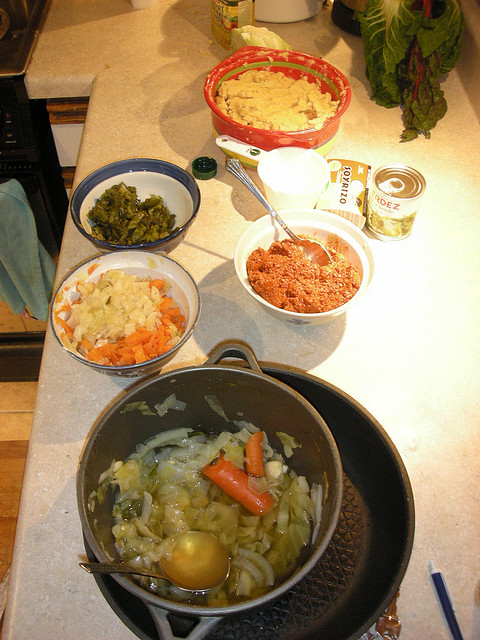Are there any cultural clues visible in the ingredients or cooking utensils? The ingredients appear to be quite general and could be found in various cuisines around the world, so it's difficult to pinpoint a specific culture. However, the presence of what looks like canned tomatoes could suggest a dish with European or American influences. The kitchen utensils and cookware are quite standard and don't provide a strong cultural clue in themselves. 